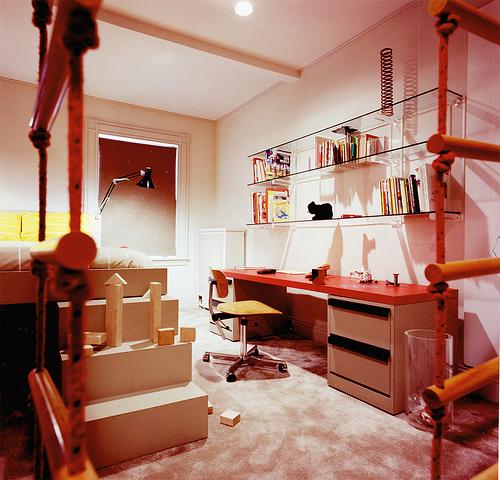What room is pictured?
Answer briefly. Bedroom. Is this a traditional room?
Answer briefly. No. Is the desk empty?
Keep it brief. No. 